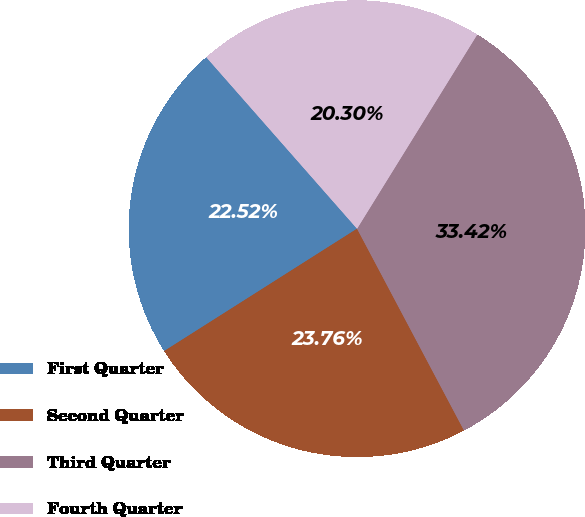Convert chart to OTSL. <chart><loc_0><loc_0><loc_500><loc_500><pie_chart><fcel>First Quarter<fcel>Second Quarter<fcel>Third Quarter<fcel>Fourth Quarter<nl><fcel>22.52%<fcel>23.76%<fcel>33.42%<fcel>20.3%<nl></chart> 